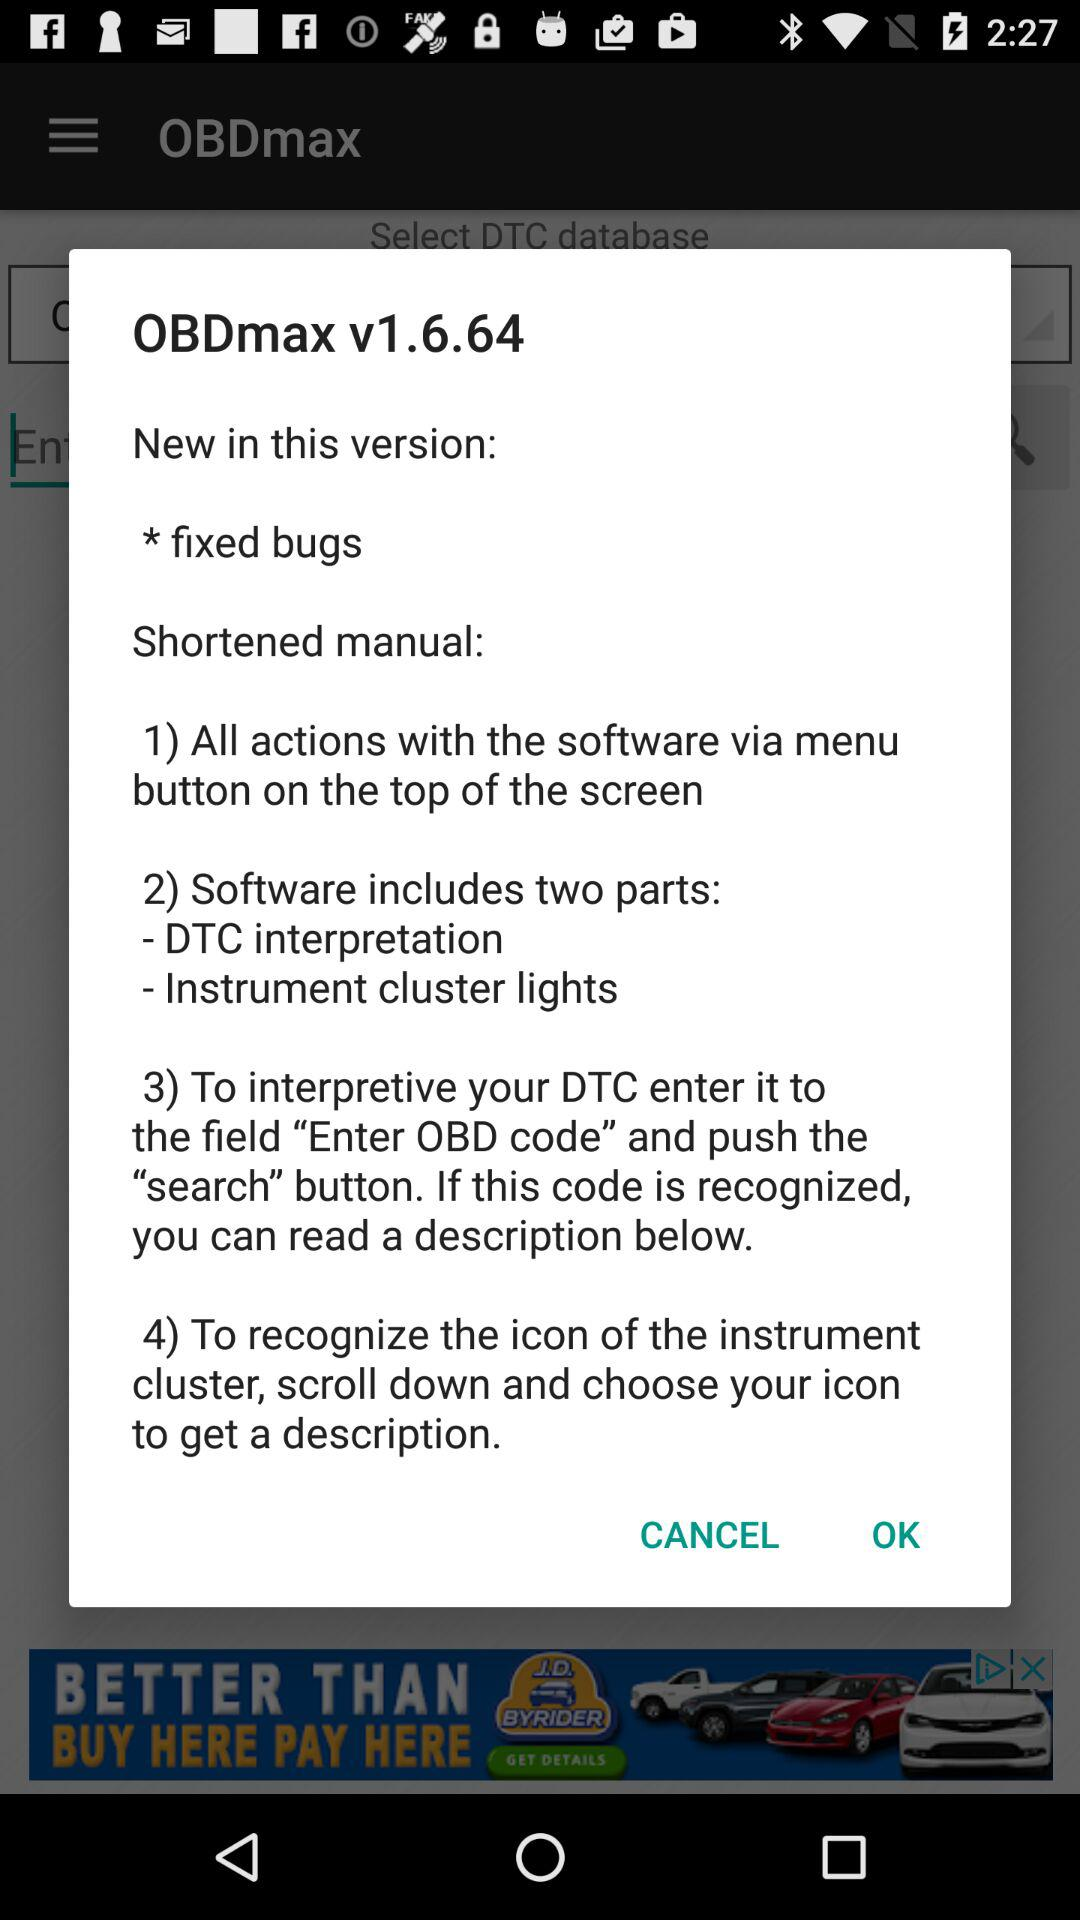How many steps are in the shortened manual?
Answer the question using a single word or phrase. 4 